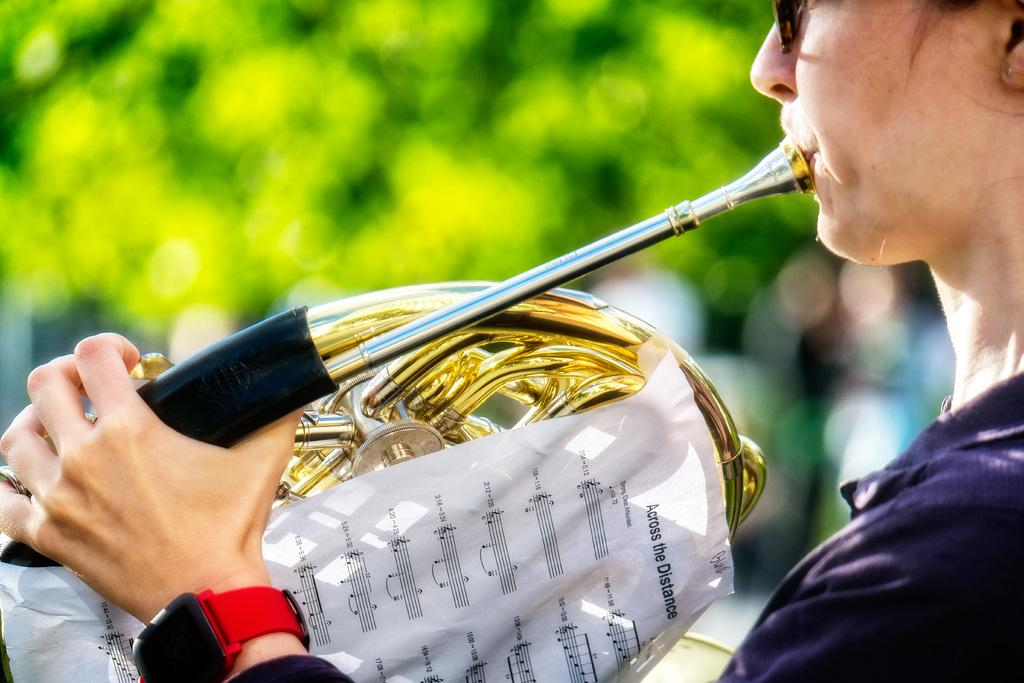Provide a one-sentence caption for the provided image. The top of the paper says across the distance. 